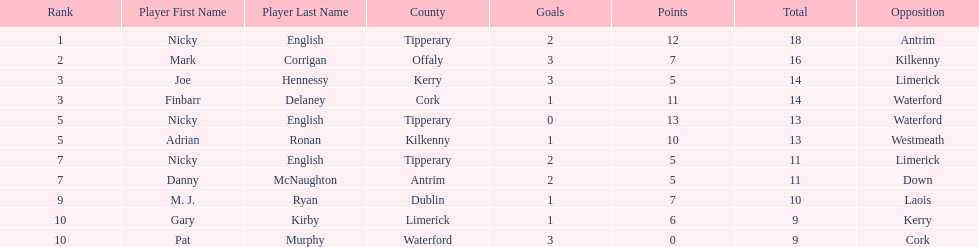What is the least total on the list? 9. 